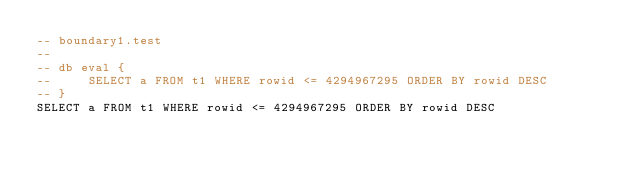<code> <loc_0><loc_0><loc_500><loc_500><_SQL_>-- boundary1.test
-- 
-- db eval {
--     SELECT a FROM t1 WHERE rowid <= 4294967295 ORDER BY rowid DESC
-- }
SELECT a FROM t1 WHERE rowid <= 4294967295 ORDER BY rowid DESC</code> 